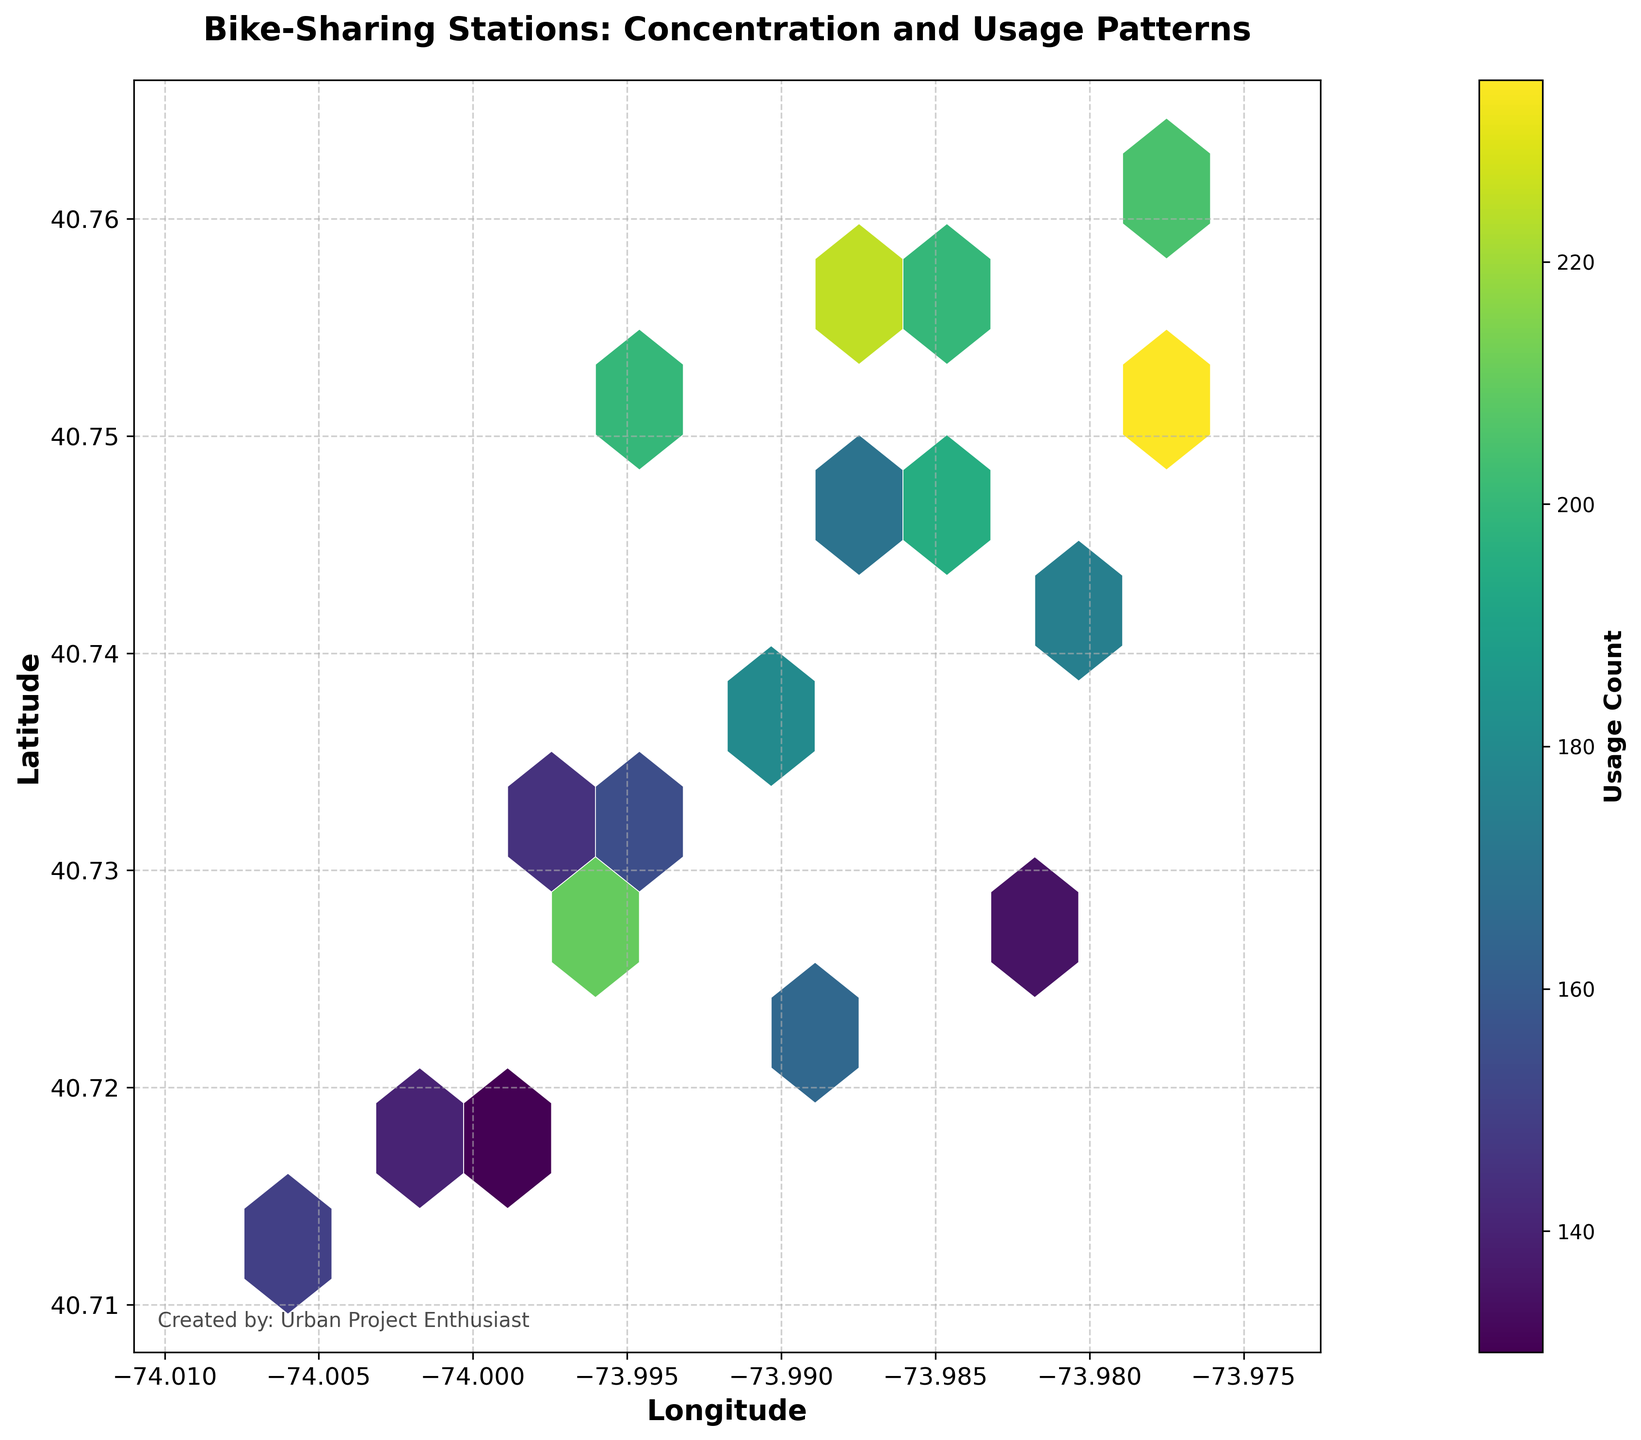Which area has the highest concentration of bike-sharing stations based on the color intensity? The area with the highest concentration of bike-sharing stations can be identified by the darkest-colored hexagons in the plot. Typically, these hexagons are concentrated towards the mid-lower center of the plot, indicating this area has the highest density of stations.
Answer: Mid-lower center What is the title of the plot? The title of the plot is typically located at the top center of the figure, providing an overview of the information presented. In this case, the title is clearly written as: "Bike-Sharing Stations: Concentration and Usage Patterns."
Answer: Bike-Sharing Stations: Concentration and Usage Patterns How many hexagons are used to represent the data in the plot? By visually counting the hexagons within the grid, it appears that there are roughly around 30 hexagons displayed, with some representing the same data points and varying in color intensity based on usage count.
Answer: Around 30 What is the range of the usage count for the bike-sharing stations? The range of the usage count can be identified from the color bar on the right side of the plot. The color bar indicates that the usage count ranges from a light color representing lower values to a dark color representing higher values. Specifically, the range lies between 130 and 235.
Answer: 130 to 235 Which area shows the lowest usage count and how can you tell? The area with the lowest usage count can be identified by the hexagons with the lightest color intensity. These hexagons are scattered mainly at the outskirts of the plot, indicating areas with less usage.
Answer: Outskirts of the plot How do the latitude and longitude ranges correlate to the area covered in the plot? The x-axis represents longitude and the y-axis represents latitude. The plot's axis labels help determine the geographic boundaries covered. By looking at the labels and the limitation set, the plot covers a small area centered around New York City coordinates from approximately 40.71° to 40.76° latitude and from -74.01° to -73.98° longitude.
Answer: Around New York City Which region has the highest usage count of 235 and can you identify it on the plot? The region with the highest usage count can be identified by locating the darkest and most saturated hexagon in the plot. This highest usage count is near the center of the plot, specifically as indicated in the hexagon around coordinates (40.7516, -73.9775).
Answer: Around coordinates (40.7516, -73.9775) Is there a noticeable pattern in the concentration of bike-sharing stations? By examining the distribution and concentration of hexagons, it appears stations are denser and have higher usage counts towards the city center or areas close to central coordinates. This pattern suggests more activity in these central regions.
Answer: Denser towards the center Are there any areas with a similar usage count and how can you identify them? Areas with similar usage counts can be identified by hexagons with similar color intensities. For example, multiple hexagons with moderate color density indicate several regions have similar moderate usage counts, typically found towards areas like the upper-right and lower-left quadrants.
Answer: Upper-right and lower-left quadrants Is there gridlines used on the plot and what purpose do they serve? Yes, gridlines in the plot are present and depicted with a dashed style; they help guide the eye to interpret coordinate positions for latitude and longitude and facilitate a clearer understanding of the data's geographic distribution.
Answer: Yes 